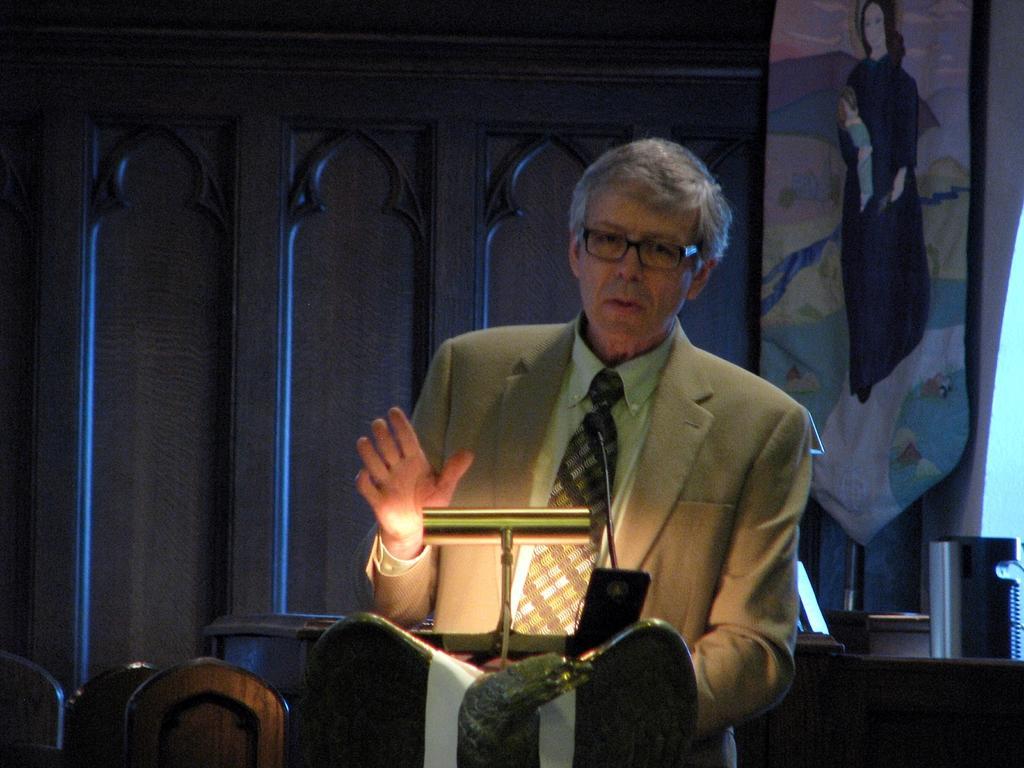How would you summarize this image in a sentence or two? In the center of the image we can see a man standing, before him there is a podium and we can see a mobile and a lamp placed on the podium. On the left there are chairs. In the background we can see a door and a curtain. 